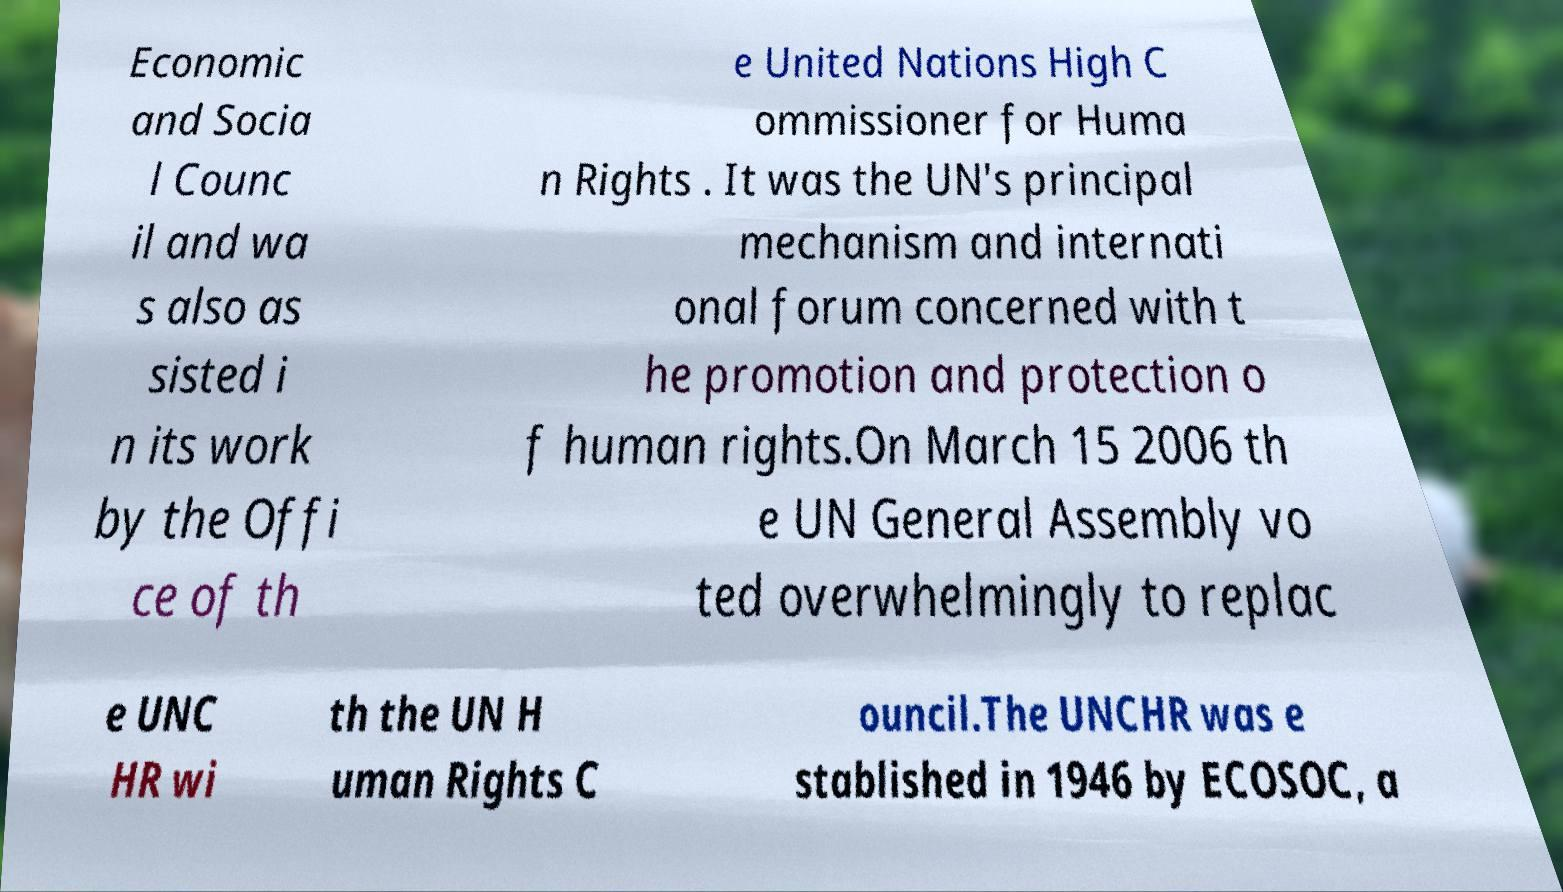Please identify and transcribe the text found in this image. Economic and Socia l Counc il and wa s also as sisted i n its work by the Offi ce of th e United Nations High C ommissioner for Huma n Rights . It was the UN's principal mechanism and internati onal forum concerned with t he promotion and protection o f human rights.On March 15 2006 th e UN General Assembly vo ted overwhelmingly to replac e UNC HR wi th the UN H uman Rights C ouncil.The UNCHR was e stablished in 1946 by ECOSOC, a 